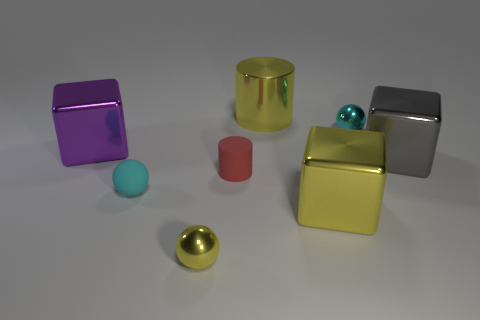Add 1 purple objects. How many objects exist? 9 Subtract all blocks. How many objects are left? 5 Add 1 red things. How many red things are left? 2 Add 1 purple metallic blocks. How many purple metallic blocks exist? 2 Subtract 0 purple cylinders. How many objects are left? 8 Subtract all gray cubes. Subtract all red matte objects. How many objects are left? 6 